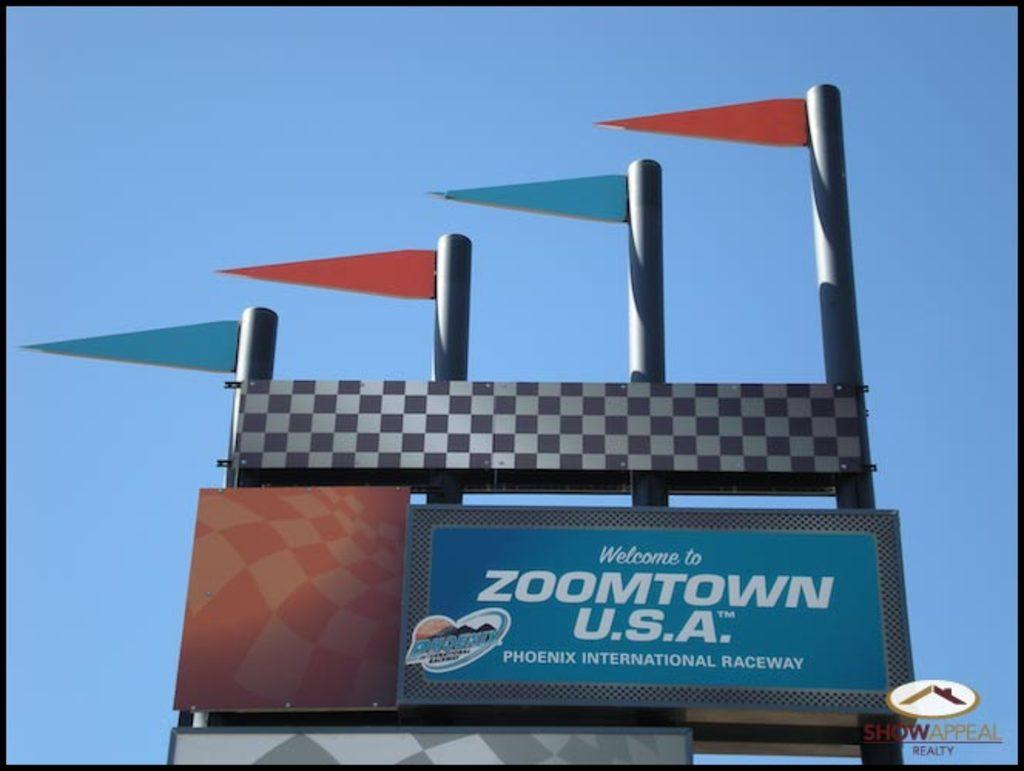<image>
Create a compact narrative representing the image presented. a billboard that says 'welcome to zoomtown u.s.a.on it 